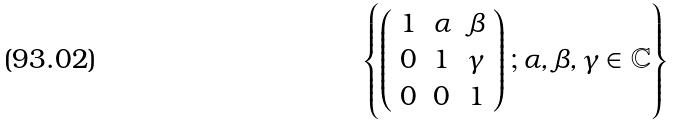Convert formula to latex. <formula><loc_0><loc_0><loc_500><loc_500>\left \{ \left ( \begin{array} { l l l } 1 & \alpha & \beta \\ 0 & 1 & \gamma \\ 0 & 0 & 1 \end{array} \right ) ; \alpha , \beta , \gamma \in \mathbb { C } \right \}</formula> 